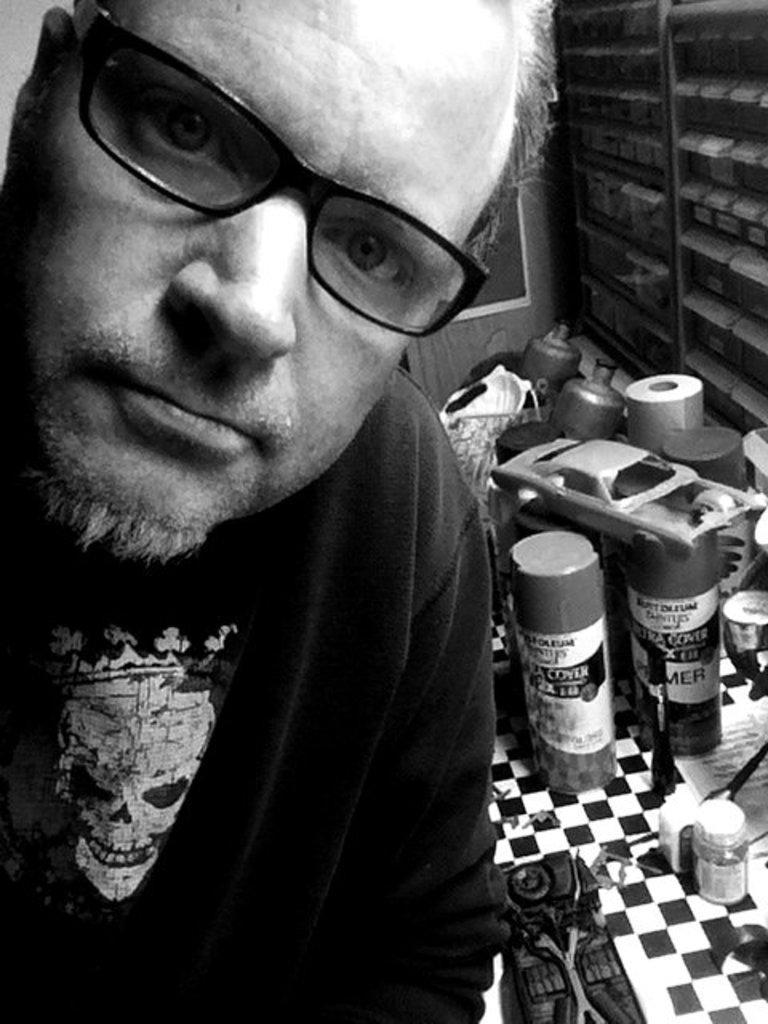Please provide a concise description of this image. On the left side of the image we can see a man, he wore spectacles, behind him we can see few bottles and other things, it is a black and white photograph. 